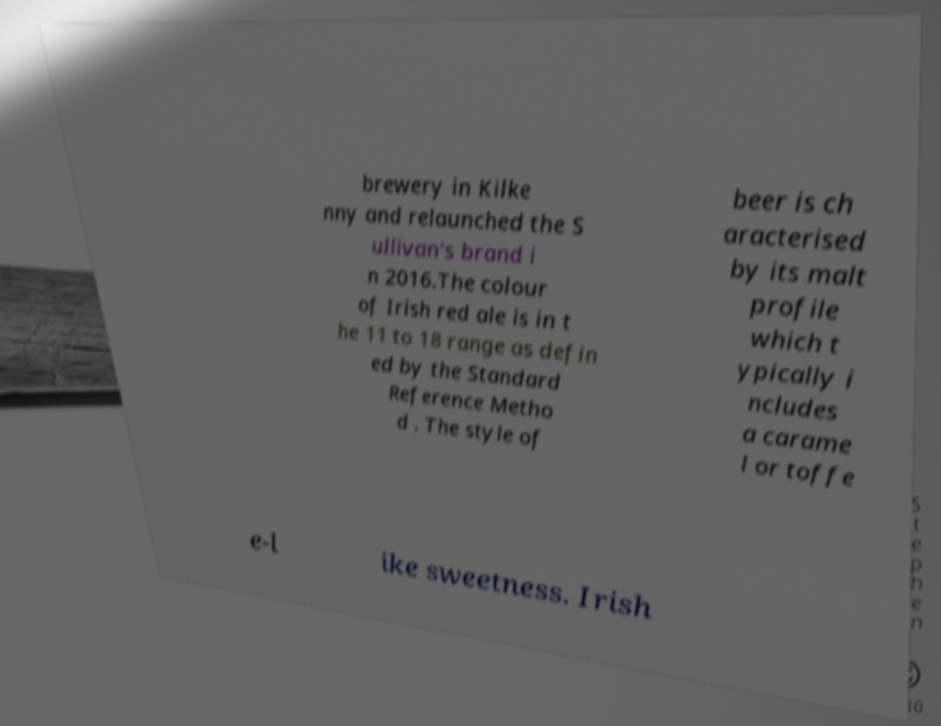Could you assist in decoding the text presented in this image and type it out clearly? brewery in Kilke nny and relaunched the S ullivan's brand i n 2016.The colour of Irish red ale is in t he 11 to 18 range as defin ed by the Standard Reference Metho d . The style of beer is ch aracterised by its malt profile which t ypically i ncludes a carame l or toffe e-l ike sweetness. Irish 